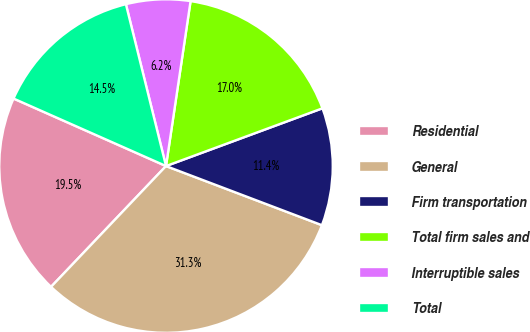Convert chart to OTSL. <chart><loc_0><loc_0><loc_500><loc_500><pie_chart><fcel>Residential<fcel>General<fcel>Firm transportation<fcel>Total firm sales and<fcel>Interruptible sales<fcel>Total<nl><fcel>19.53%<fcel>31.34%<fcel>11.4%<fcel>17.02%<fcel>6.22%<fcel>14.5%<nl></chart> 